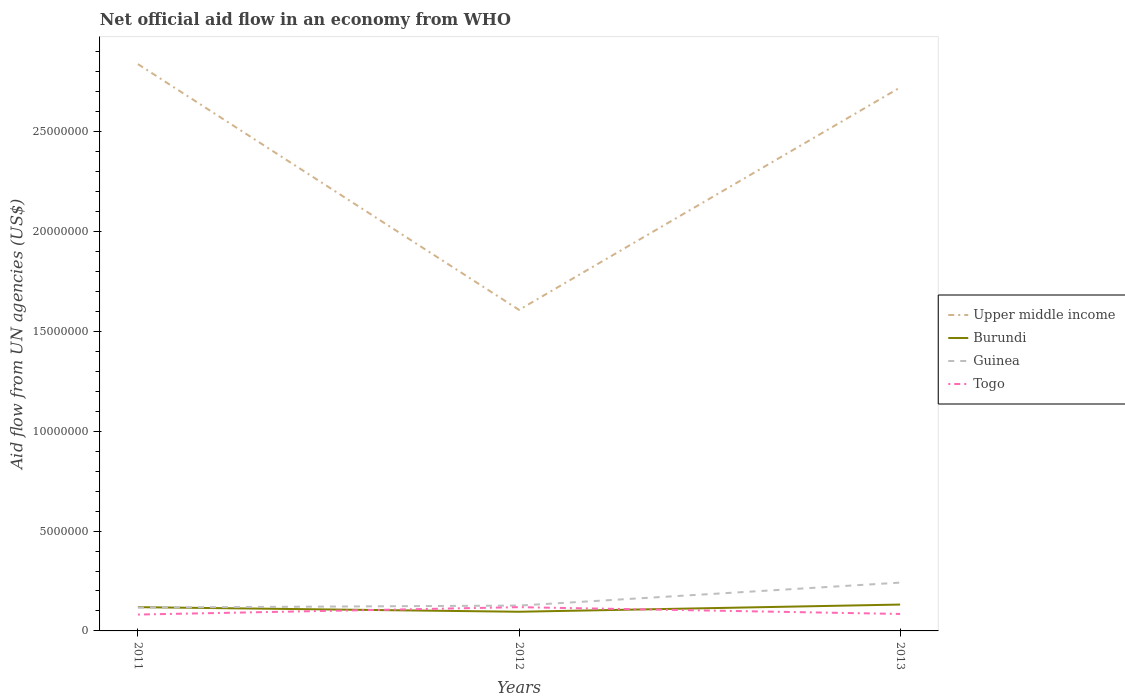Across all years, what is the maximum net official aid flow in Guinea?
Your response must be concise. 1.17e+06. In which year was the net official aid flow in Burundi maximum?
Ensure brevity in your answer.  2012. What is the total net official aid flow in Upper middle income in the graph?
Offer a terse response. 1.23e+07. What is the difference between the highest and the second highest net official aid flow in Upper middle income?
Provide a succinct answer. 1.23e+07. How many lines are there?
Make the answer very short. 4. Are the values on the major ticks of Y-axis written in scientific E-notation?
Make the answer very short. No. Does the graph contain grids?
Give a very brief answer. No. How many legend labels are there?
Your answer should be compact. 4. How are the legend labels stacked?
Ensure brevity in your answer.  Vertical. What is the title of the graph?
Your answer should be compact. Net official aid flow in an economy from WHO. Does "Slovenia" appear as one of the legend labels in the graph?
Ensure brevity in your answer.  No. What is the label or title of the X-axis?
Give a very brief answer. Years. What is the label or title of the Y-axis?
Make the answer very short. Aid flow from UN agencies (US$). What is the Aid flow from UN agencies (US$) in Upper middle income in 2011?
Offer a terse response. 2.84e+07. What is the Aid flow from UN agencies (US$) of Burundi in 2011?
Your answer should be very brief. 1.19e+06. What is the Aid flow from UN agencies (US$) in Guinea in 2011?
Offer a very short reply. 1.17e+06. What is the Aid flow from UN agencies (US$) of Togo in 2011?
Provide a short and direct response. 8.20e+05. What is the Aid flow from UN agencies (US$) of Upper middle income in 2012?
Offer a very short reply. 1.61e+07. What is the Aid flow from UN agencies (US$) of Burundi in 2012?
Offer a very short reply. 9.60e+05. What is the Aid flow from UN agencies (US$) in Guinea in 2012?
Make the answer very short. 1.27e+06. What is the Aid flow from UN agencies (US$) in Togo in 2012?
Your response must be concise. 1.19e+06. What is the Aid flow from UN agencies (US$) of Upper middle income in 2013?
Your answer should be compact. 2.72e+07. What is the Aid flow from UN agencies (US$) of Burundi in 2013?
Make the answer very short. 1.32e+06. What is the Aid flow from UN agencies (US$) of Guinea in 2013?
Your answer should be compact. 2.42e+06. What is the Aid flow from UN agencies (US$) of Togo in 2013?
Your response must be concise. 8.50e+05. Across all years, what is the maximum Aid flow from UN agencies (US$) of Upper middle income?
Ensure brevity in your answer.  2.84e+07. Across all years, what is the maximum Aid flow from UN agencies (US$) of Burundi?
Give a very brief answer. 1.32e+06. Across all years, what is the maximum Aid flow from UN agencies (US$) of Guinea?
Your answer should be compact. 2.42e+06. Across all years, what is the maximum Aid flow from UN agencies (US$) of Togo?
Give a very brief answer. 1.19e+06. Across all years, what is the minimum Aid flow from UN agencies (US$) of Upper middle income?
Make the answer very short. 1.61e+07. Across all years, what is the minimum Aid flow from UN agencies (US$) of Burundi?
Provide a short and direct response. 9.60e+05. Across all years, what is the minimum Aid flow from UN agencies (US$) of Guinea?
Ensure brevity in your answer.  1.17e+06. Across all years, what is the minimum Aid flow from UN agencies (US$) of Togo?
Offer a terse response. 8.20e+05. What is the total Aid flow from UN agencies (US$) of Upper middle income in the graph?
Your answer should be very brief. 7.17e+07. What is the total Aid flow from UN agencies (US$) of Burundi in the graph?
Give a very brief answer. 3.47e+06. What is the total Aid flow from UN agencies (US$) in Guinea in the graph?
Provide a succinct answer. 4.86e+06. What is the total Aid flow from UN agencies (US$) of Togo in the graph?
Your answer should be compact. 2.86e+06. What is the difference between the Aid flow from UN agencies (US$) in Upper middle income in 2011 and that in 2012?
Your response must be concise. 1.23e+07. What is the difference between the Aid flow from UN agencies (US$) of Guinea in 2011 and that in 2012?
Provide a succinct answer. -1.00e+05. What is the difference between the Aid flow from UN agencies (US$) in Togo in 2011 and that in 2012?
Make the answer very short. -3.70e+05. What is the difference between the Aid flow from UN agencies (US$) of Upper middle income in 2011 and that in 2013?
Offer a terse response. 1.17e+06. What is the difference between the Aid flow from UN agencies (US$) in Guinea in 2011 and that in 2013?
Ensure brevity in your answer.  -1.25e+06. What is the difference between the Aid flow from UN agencies (US$) of Upper middle income in 2012 and that in 2013?
Give a very brief answer. -1.11e+07. What is the difference between the Aid flow from UN agencies (US$) in Burundi in 2012 and that in 2013?
Your response must be concise. -3.60e+05. What is the difference between the Aid flow from UN agencies (US$) in Guinea in 2012 and that in 2013?
Offer a terse response. -1.15e+06. What is the difference between the Aid flow from UN agencies (US$) of Upper middle income in 2011 and the Aid flow from UN agencies (US$) of Burundi in 2012?
Ensure brevity in your answer.  2.74e+07. What is the difference between the Aid flow from UN agencies (US$) of Upper middle income in 2011 and the Aid flow from UN agencies (US$) of Guinea in 2012?
Provide a short and direct response. 2.71e+07. What is the difference between the Aid flow from UN agencies (US$) in Upper middle income in 2011 and the Aid flow from UN agencies (US$) in Togo in 2012?
Offer a very short reply. 2.72e+07. What is the difference between the Aid flow from UN agencies (US$) of Burundi in 2011 and the Aid flow from UN agencies (US$) of Guinea in 2012?
Your response must be concise. -8.00e+04. What is the difference between the Aid flow from UN agencies (US$) in Burundi in 2011 and the Aid flow from UN agencies (US$) in Togo in 2012?
Your response must be concise. 0. What is the difference between the Aid flow from UN agencies (US$) of Guinea in 2011 and the Aid flow from UN agencies (US$) of Togo in 2012?
Provide a succinct answer. -2.00e+04. What is the difference between the Aid flow from UN agencies (US$) in Upper middle income in 2011 and the Aid flow from UN agencies (US$) in Burundi in 2013?
Your response must be concise. 2.71e+07. What is the difference between the Aid flow from UN agencies (US$) of Upper middle income in 2011 and the Aid flow from UN agencies (US$) of Guinea in 2013?
Provide a succinct answer. 2.60e+07. What is the difference between the Aid flow from UN agencies (US$) in Upper middle income in 2011 and the Aid flow from UN agencies (US$) in Togo in 2013?
Offer a terse response. 2.75e+07. What is the difference between the Aid flow from UN agencies (US$) of Burundi in 2011 and the Aid flow from UN agencies (US$) of Guinea in 2013?
Offer a very short reply. -1.23e+06. What is the difference between the Aid flow from UN agencies (US$) of Guinea in 2011 and the Aid flow from UN agencies (US$) of Togo in 2013?
Your answer should be very brief. 3.20e+05. What is the difference between the Aid flow from UN agencies (US$) in Upper middle income in 2012 and the Aid flow from UN agencies (US$) in Burundi in 2013?
Ensure brevity in your answer.  1.48e+07. What is the difference between the Aid flow from UN agencies (US$) in Upper middle income in 2012 and the Aid flow from UN agencies (US$) in Guinea in 2013?
Make the answer very short. 1.37e+07. What is the difference between the Aid flow from UN agencies (US$) in Upper middle income in 2012 and the Aid flow from UN agencies (US$) in Togo in 2013?
Your response must be concise. 1.52e+07. What is the difference between the Aid flow from UN agencies (US$) of Burundi in 2012 and the Aid flow from UN agencies (US$) of Guinea in 2013?
Your answer should be very brief. -1.46e+06. What is the difference between the Aid flow from UN agencies (US$) of Burundi in 2012 and the Aid flow from UN agencies (US$) of Togo in 2013?
Your answer should be compact. 1.10e+05. What is the difference between the Aid flow from UN agencies (US$) in Guinea in 2012 and the Aid flow from UN agencies (US$) in Togo in 2013?
Provide a succinct answer. 4.20e+05. What is the average Aid flow from UN agencies (US$) of Upper middle income per year?
Your answer should be compact. 2.39e+07. What is the average Aid flow from UN agencies (US$) in Burundi per year?
Your answer should be very brief. 1.16e+06. What is the average Aid flow from UN agencies (US$) in Guinea per year?
Provide a short and direct response. 1.62e+06. What is the average Aid flow from UN agencies (US$) of Togo per year?
Make the answer very short. 9.53e+05. In the year 2011, what is the difference between the Aid flow from UN agencies (US$) of Upper middle income and Aid flow from UN agencies (US$) of Burundi?
Make the answer very short. 2.72e+07. In the year 2011, what is the difference between the Aid flow from UN agencies (US$) of Upper middle income and Aid flow from UN agencies (US$) of Guinea?
Your response must be concise. 2.72e+07. In the year 2011, what is the difference between the Aid flow from UN agencies (US$) of Upper middle income and Aid flow from UN agencies (US$) of Togo?
Keep it short and to the point. 2.76e+07. In the year 2011, what is the difference between the Aid flow from UN agencies (US$) of Burundi and Aid flow from UN agencies (US$) of Togo?
Ensure brevity in your answer.  3.70e+05. In the year 2011, what is the difference between the Aid flow from UN agencies (US$) of Guinea and Aid flow from UN agencies (US$) of Togo?
Ensure brevity in your answer.  3.50e+05. In the year 2012, what is the difference between the Aid flow from UN agencies (US$) in Upper middle income and Aid flow from UN agencies (US$) in Burundi?
Provide a short and direct response. 1.51e+07. In the year 2012, what is the difference between the Aid flow from UN agencies (US$) in Upper middle income and Aid flow from UN agencies (US$) in Guinea?
Your response must be concise. 1.48e+07. In the year 2012, what is the difference between the Aid flow from UN agencies (US$) in Upper middle income and Aid flow from UN agencies (US$) in Togo?
Give a very brief answer. 1.49e+07. In the year 2012, what is the difference between the Aid flow from UN agencies (US$) in Burundi and Aid flow from UN agencies (US$) in Guinea?
Your answer should be very brief. -3.10e+05. In the year 2012, what is the difference between the Aid flow from UN agencies (US$) in Guinea and Aid flow from UN agencies (US$) in Togo?
Ensure brevity in your answer.  8.00e+04. In the year 2013, what is the difference between the Aid flow from UN agencies (US$) in Upper middle income and Aid flow from UN agencies (US$) in Burundi?
Make the answer very short. 2.59e+07. In the year 2013, what is the difference between the Aid flow from UN agencies (US$) of Upper middle income and Aid flow from UN agencies (US$) of Guinea?
Give a very brief answer. 2.48e+07. In the year 2013, what is the difference between the Aid flow from UN agencies (US$) of Upper middle income and Aid flow from UN agencies (US$) of Togo?
Offer a terse response. 2.64e+07. In the year 2013, what is the difference between the Aid flow from UN agencies (US$) of Burundi and Aid flow from UN agencies (US$) of Guinea?
Your response must be concise. -1.10e+06. In the year 2013, what is the difference between the Aid flow from UN agencies (US$) of Guinea and Aid flow from UN agencies (US$) of Togo?
Make the answer very short. 1.57e+06. What is the ratio of the Aid flow from UN agencies (US$) in Upper middle income in 2011 to that in 2012?
Keep it short and to the point. 1.77. What is the ratio of the Aid flow from UN agencies (US$) of Burundi in 2011 to that in 2012?
Provide a succinct answer. 1.24. What is the ratio of the Aid flow from UN agencies (US$) in Guinea in 2011 to that in 2012?
Offer a terse response. 0.92. What is the ratio of the Aid flow from UN agencies (US$) in Togo in 2011 to that in 2012?
Provide a succinct answer. 0.69. What is the ratio of the Aid flow from UN agencies (US$) of Upper middle income in 2011 to that in 2013?
Your answer should be compact. 1.04. What is the ratio of the Aid flow from UN agencies (US$) of Burundi in 2011 to that in 2013?
Make the answer very short. 0.9. What is the ratio of the Aid flow from UN agencies (US$) in Guinea in 2011 to that in 2013?
Keep it short and to the point. 0.48. What is the ratio of the Aid flow from UN agencies (US$) of Togo in 2011 to that in 2013?
Your response must be concise. 0.96. What is the ratio of the Aid flow from UN agencies (US$) in Upper middle income in 2012 to that in 2013?
Keep it short and to the point. 0.59. What is the ratio of the Aid flow from UN agencies (US$) of Burundi in 2012 to that in 2013?
Provide a short and direct response. 0.73. What is the ratio of the Aid flow from UN agencies (US$) of Guinea in 2012 to that in 2013?
Your response must be concise. 0.52. What is the difference between the highest and the second highest Aid flow from UN agencies (US$) in Upper middle income?
Offer a very short reply. 1.17e+06. What is the difference between the highest and the second highest Aid flow from UN agencies (US$) in Guinea?
Offer a very short reply. 1.15e+06. What is the difference between the highest and the second highest Aid flow from UN agencies (US$) of Togo?
Offer a very short reply. 3.40e+05. What is the difference between the highest and the lowest Aid flow from UN agencies (US$) of Upper middle income?
Provide a succinct answer. 1.23e+07. What is the difference between the highest and the lowest Aid flow from UN agencies (US$) in Guinea?
Your answer should be compact. 1.25e+06. 